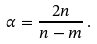<formula> <loc_0><loc_0><loc_500><loc_500>\alpha = \frac { 2 n } { n - m } \, .</formula> 